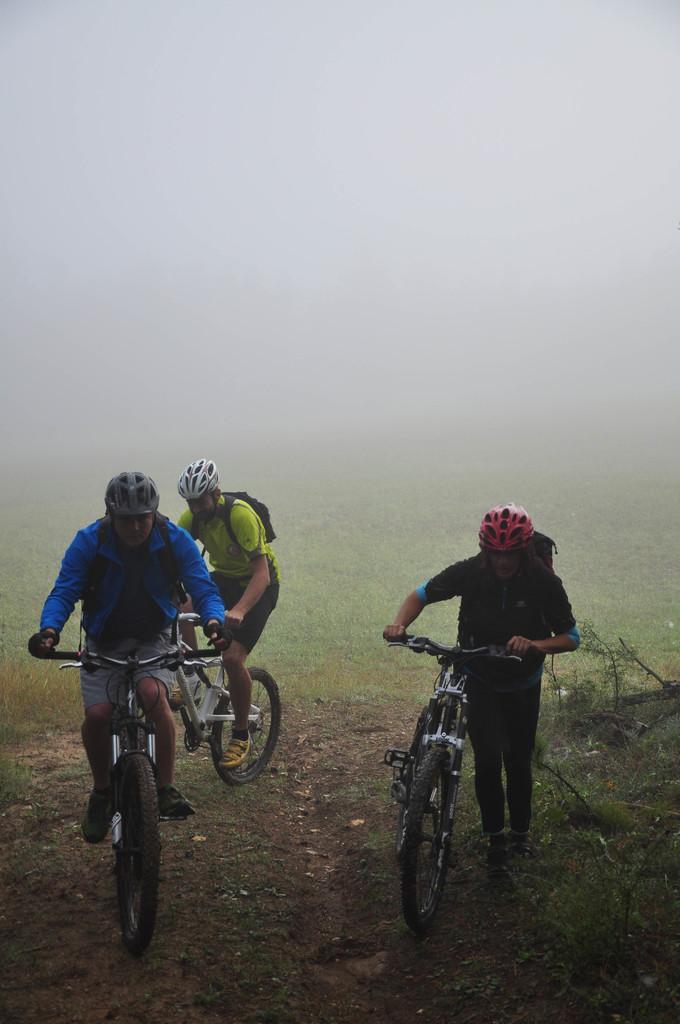Describe this image in one or two sentences. In this image there are two people riding bicycle on the path, beside them there is another person walking along with the bicycle, there are few wooden sticks and plants on the surface of the grass. In the background there is a snow in the air. 